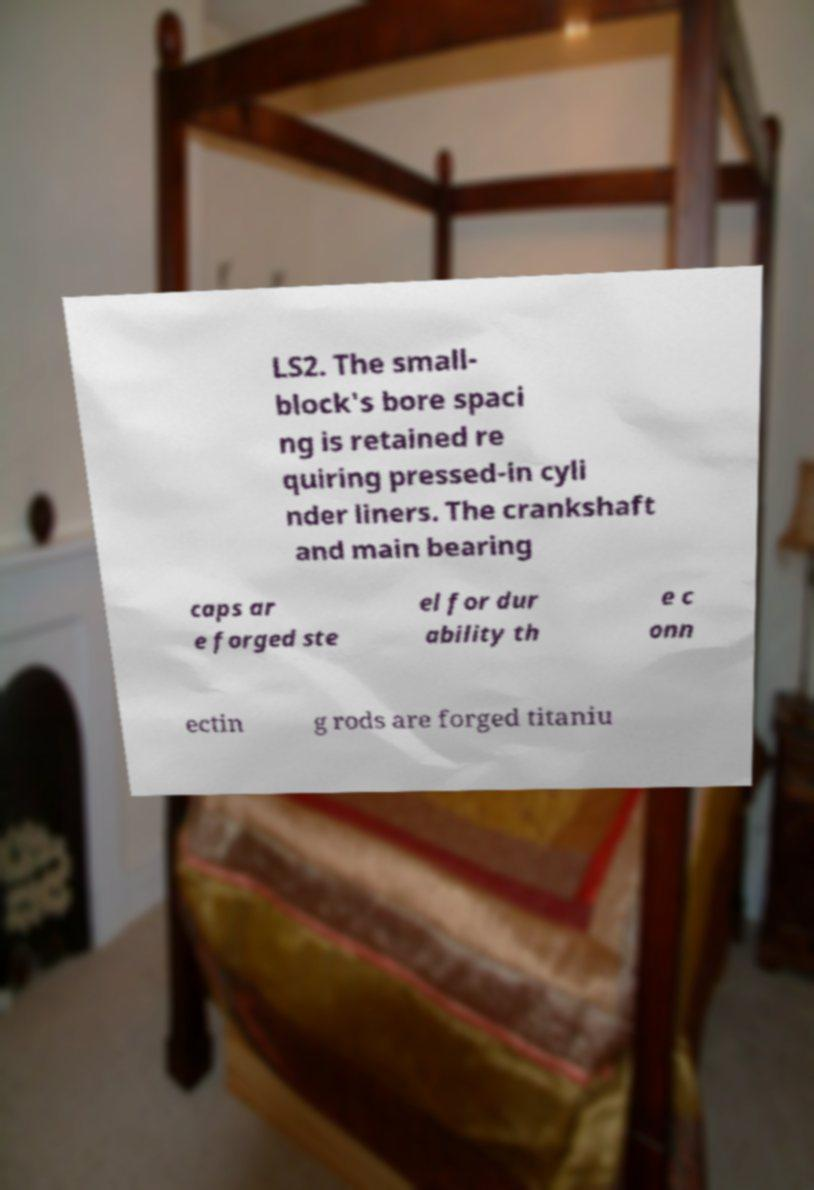Please identify and transcribe the text found in this image. LS2. The small- block's bore spaci ng is retained re quiring pressed-in cyli nder liners. The crankshaft and main bearing caps ar e forged ste el for dur ability th e c onn ectin g rods are forged titaniu 